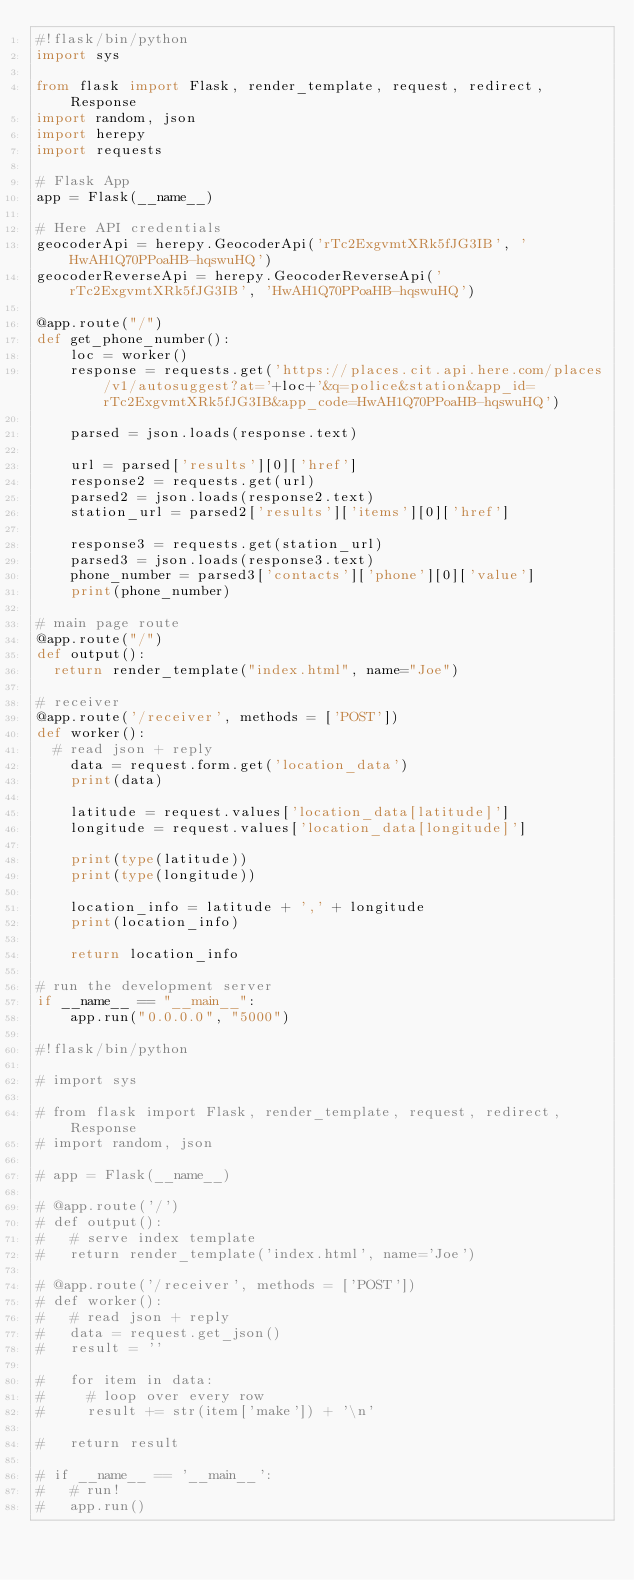<code> <loc_0><loc_0><loc_500><loc_500><_Python_>#!flask/bin/python
import sys

from flask import Flask, render_template, request, redirect, Response
import random, json
import herepy
import requests

# Flask App
app = Flask(__name__)

# Here API credentials
geocoderApi = herepy.GeocoderApi('rTc2ExgvmtXRk5fJG3IB', 'HwAH1Q70PPoaHB-hqswuHQ')
geocoderReverseApi = herepy.GeocoderReverseApi('rTc2ExgvmtXRk5fJG3IB', 'HwAH1Q70PPoaHB-hqswuHQ')

@app.route("/")
def get_phone_number():
    loc = worker()
    response = requests.get('https://places.cit.api.here.com/places/v1/autosuggest?at='+loc+'&q=police&station&app_id=rTc2ExgvmtXRk5fJG3IB&app_code=HwAH1Q70PPoaHB-hqswuHQ')

    parsed = json.loads(response.text)

    url = parsed['results'][0]['href']
    response2 = requests.get(url)
    parsed2 = json.loads(response2.text)
    station_url = parsed2['results']['items'][0]['href']

    response3 = requests.get(station_url)
    parsed3 = json.loads(response3.text)
    phone_number = parsed3['contacts']['phone'][0]['value']
    print(phone_number)

# main page route
@app.route("/")
def output():
	return render_template("index.html", name="Joe")

# receiver
@app.route('/receiver', methods = ['POST'])
def worker():
	# read json + reply
    data = request.form.get('location_data')
    print(data)
    
    latitude = request.values['location_data[latitude]']
    longitude = request.values['location_data[longitude]']

    print(type(latitude))
    print(type(longitude))

    location_info = latitude + ',' + longitude
    print(location_info)

    return location_info

# run the development server
if __name__ == "__main__":
    app.run("0.0.0.0", "5000")

#!flask/bin/python

# import sys

# from flask import Flask, render_template, request, redirect, Response
# import random, json

# app = Flask(__name__)

# @app.route('/')
# def output():
# 	# serve index template
# 	return render_template('index.html', name='Joe')

# @app.route('/receiver', methods = ['POST'])
# def worker():
# 	# read json + reply
# 	data = request.get_json()
# 	result = ''

# 	for item in data:
# 		# loop over every row
# 		result += str(item['make']) + '\n'

# 	return result

# if __name__ == '__main__':
# 	# run!
# 	app.run()</code> 